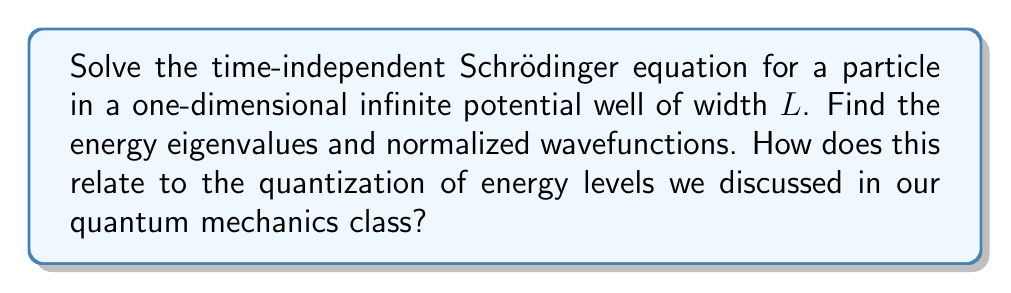Teach me how to tackle this problem. 1) The time-independent Schrödinger equation is:

   $$-\frac{\hbar^2}{2m}\frac{d^2\psi}{dx^2} + V(x)\psi = E\psi$$

2) For an infinite potential well of width $L$, $V(x) = 0$ for $0 < x < L$, and $V(x) = \infty$ elsewhere.

3) Inside the well, the equation becomes:

   $$-\frac{\hbar^2}{2m}\frac{d^2\psi}{dx^2} = E\psi$$

4) This has the general solution:

   $$\psi(x) = A\sin(kx) + B\cos(kx)$$

   where $k = \sqrt{\frac{2mE}{\hbar^2}}$

5) Boundary conditions: $\psi(0) = \psi(L) = 0$ (wavefunction vanishes at the walls)

6) $\psi(0) = 0$ implies $B = 0$
   $\psi(L) = 0$ implies $A\sin(kL) = 0$

7) For non-trivial solutions, $kL = n\pi$, where $n = 1, 2, 3, ...$

8) Energy eigenvalues:

   $$E_n = \frac{\hbar^2k^2}{2m} = \frac{n^2\pi^2\hbar^2}{2mL^2}$$

9) Normalized wavefunctions:

   $$\psi_n(x) = \sqrt{\frac{2}{L}}\sin(\frac{n\pi x}{L})$$

This result shows that energy is quantized, with discrete energy levels depending on the quantum number $n$. This quantization is a fundamental concept in quantum mechanics, demonstrating the particle-in-a-box model we studied in our class.
Answer: $E_n = \frac{n^2\pi^2\hbar^2}{2mL^2}$, $\psi_n(x) = \sqrt{\frac{2}{L}}\sin(\frac{n\pi x}{L})$ 